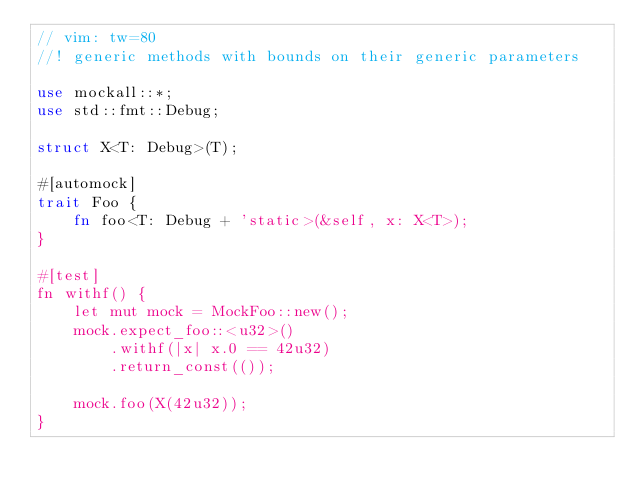Convert code to text. <code><loc_0><loc_0><loc_500><loc_500><_Rust_>// vim: tw=80
//! generic methods with bounds on their generic parameters

use mockall::*;
use std::fmt::Debug;

struct X<T: Debug>(T);

#[automock]
trait Foo {
    fn foo<T: Debug + 'static>(&self, x: X<T>);
}

#[test]
fn withf() {
    let mut mock = MockFoo::new();
    mock.expect_foo::<u32>()
        .withf(|x| x.0 == 42u32)
        .return_const(());

    mock.foo(X(42u32));
}
</code> 